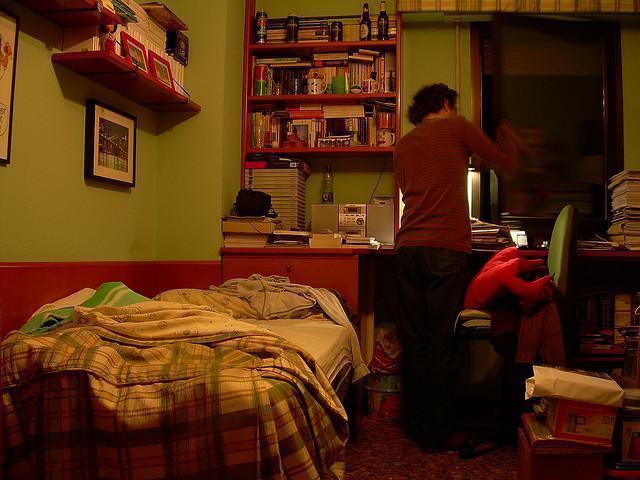What is in the room?
Choose the right answer from the provided options to respond to the question.
Options: Bed, witch hat, pool table, refrigerator. Bed. 